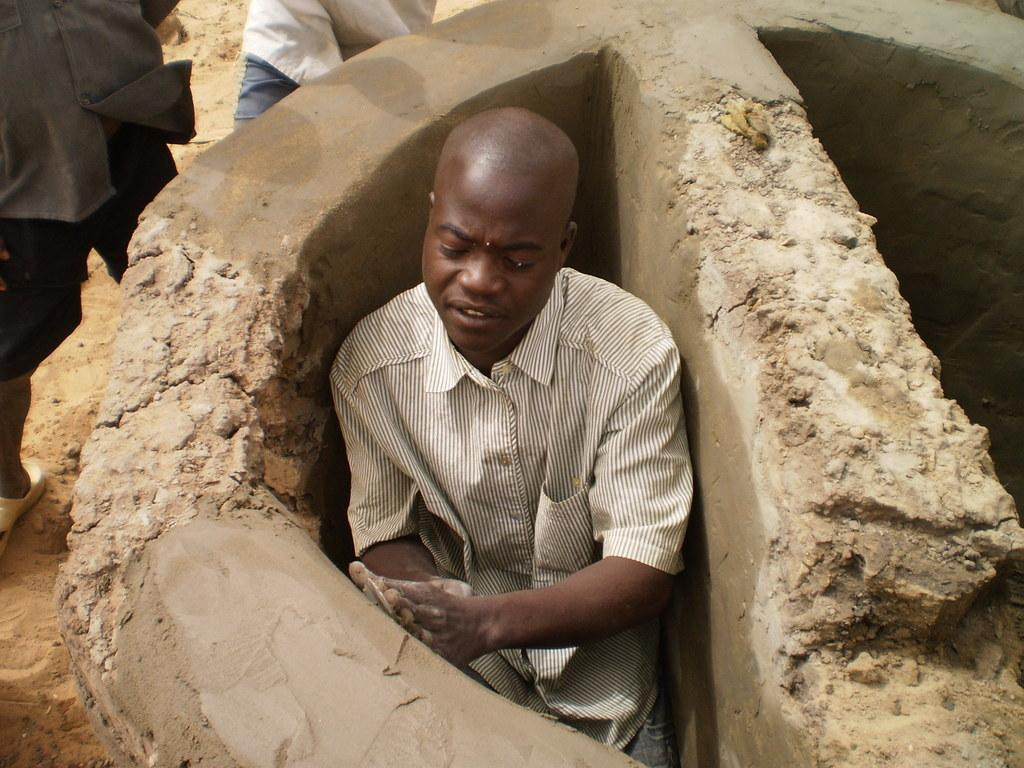What is the man in the image doing? The man in the image is plastering the wall. Can you describe the activity of the two persons in the background of the image? The two persons are standing on the sand in the background of the image. What type of brick is the man using to play with the grain in the image? There is no brick or grain present in the image, and the man is not playing. He is plastering the wall. 